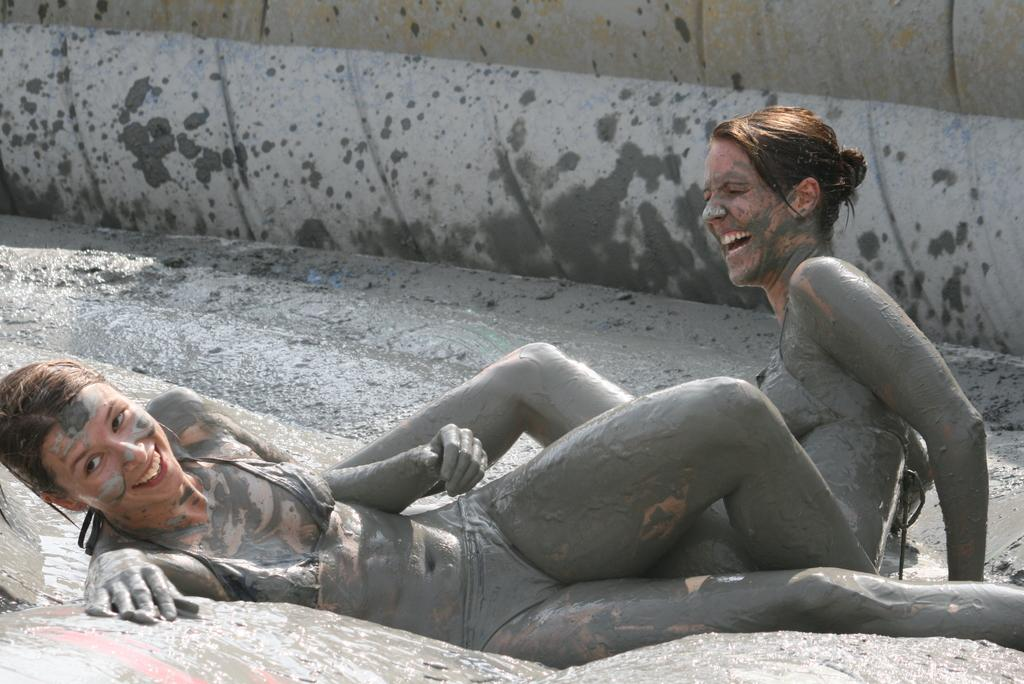How many people are in the image? There are two women in the image. What is the condition of the ground in the image? The women are in the mud. What is the emotional state of the women in the image? The women are laughing. What type of loaf is being used by the women in the image? There is no loaf present in the image. How tall are the giants in the image? There are no giants present in the image. 